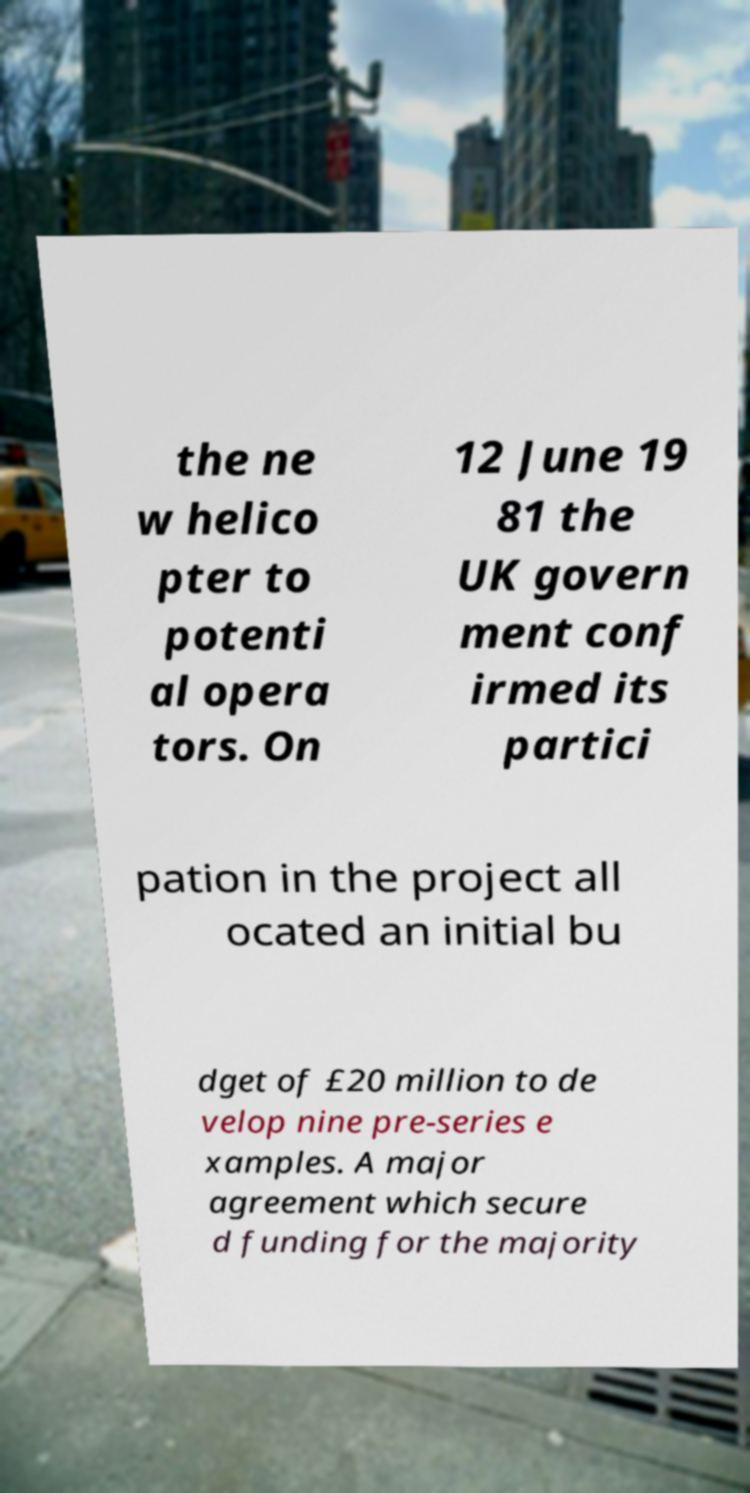Please identify and transcribe the text found in this image. the ne w helico pter to potenti al opera tors. On 12 June 19 81 the UK govern ment conf irmed its partici pation in the project all ocated an initial bu dget of £20 million to de velop nine pre-series e xamples. A major agreement which secure d funding for the majority 